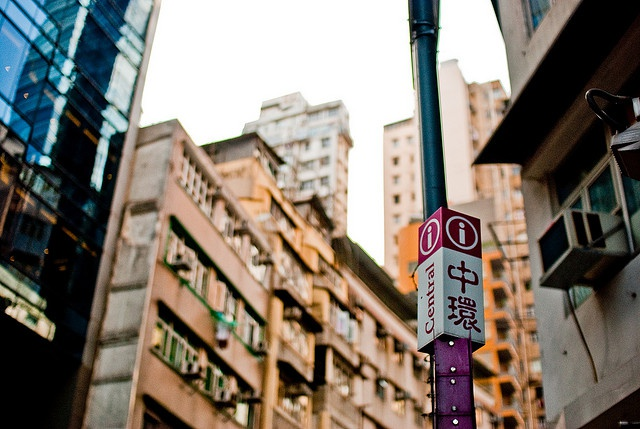Describe the objects in this image and their specific colors. I can see various objects in this image with different colors. 